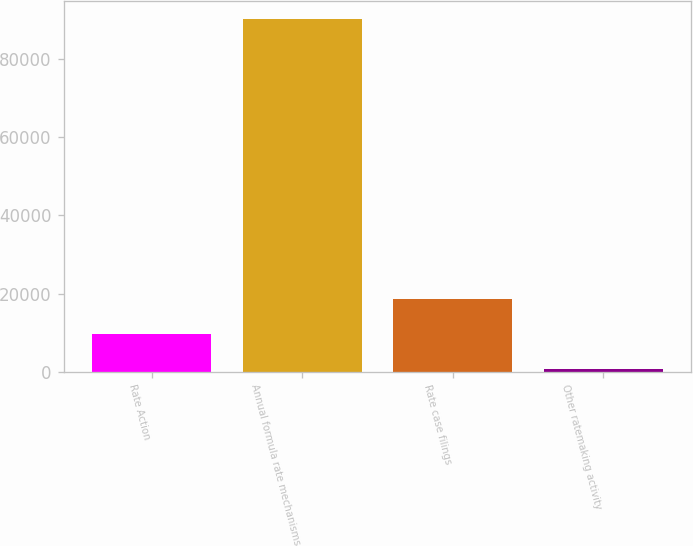<chart> <loc_0><loc_0><loc_500><loc_500><bar_chart><fcel>Rate Action<fcel>Annual formula rate mechanisms<fcel>Rate case filings<fcel>Other ratemaking activity<nl><fcel>9748.3<fcel>90427<fcel>18712.6<fcel>784<nl></chart> 